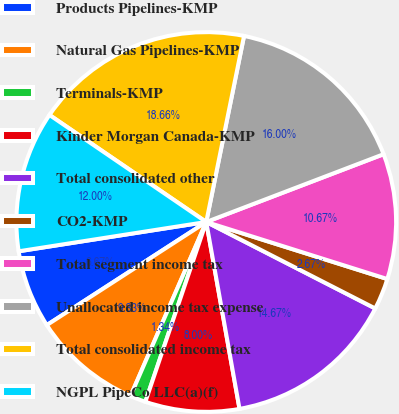Convert chart. <chart><loc_0><loc_0><loc_500><loc_500><pie_chart><fcel>Products Pipelines-KMP<fcel>Natural Gas Pipelines-KMP<fcel>Terminals-KMP<fcel>Kinder Morgan Canada-KMP<fcel>Total consolidated other<fcel>CO2-KMP<fcel>Total segment income tax<fcel>Unallocated income tax expense<fcel>Total consolidated income tax<fcel>NGPL PipeCo LLC(a)(f)<nl><fcel>6.67%<fcel>9.33%<fcel>1.34%<fcel>8.0%<fcel>14.67%<fcel>2.67%<fcel>10.67%<fcel>16.0%<fcel>18.66%<fcel>12.0%<nl></chart> 